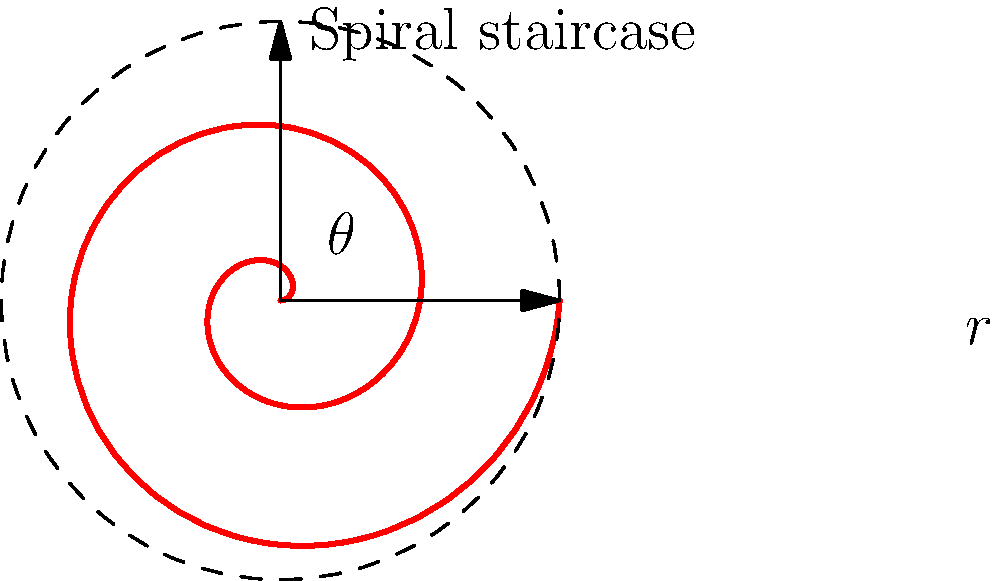In the haunted lighthouse, you encounter a mysterious spiral staircase. The staircase follows an Archimedean spiral, where the distance from the center increases linearly with the angle of rotation. If the staircase makes 2 complete revolutions and has a total height of 10 meters, what is the angle (in radians) between two consecutive steps if there are 40 steps in total? Assume the spiral starts at the origin. Let's approach this step-by-step:

1) An Archimedean spiral is defined by the equation $r = a\theta$, where $r$ is the distance from the center, $a$ is a constant, and $\theta$ is the angle of rotation.

2) We know the staircase makes 2 complete revolutions, so the total angle covered is:
   $\theta_{total} = 4\pi$ radians

3) The height of the staircase can be related to the angle using the equation:
   $h = b\theta$
   where $h$ is the height and $b$ is another constant.

4) We're given that the total height is 10 meters when $\theta = 4\pi$, so:
   $10 = b(4\pi)$
   $b = \frac{10}{4\pi} = \frac{5}{2\pi}$

5) Now, we need to find the angle between two consecutive steps. There are 40 steps in total, so we need to divide the total angle by 40:

   $\theta_{step} = \frac{\theta_{total}}{40} = \frac{4\pi}{40} = \frac{\pi}{10}$ radians

Therefore, the angle between two consecutive steps is $\frac{\pi}{10}$ radians.
Answer: $\frac{\pi}{10}$ radians 